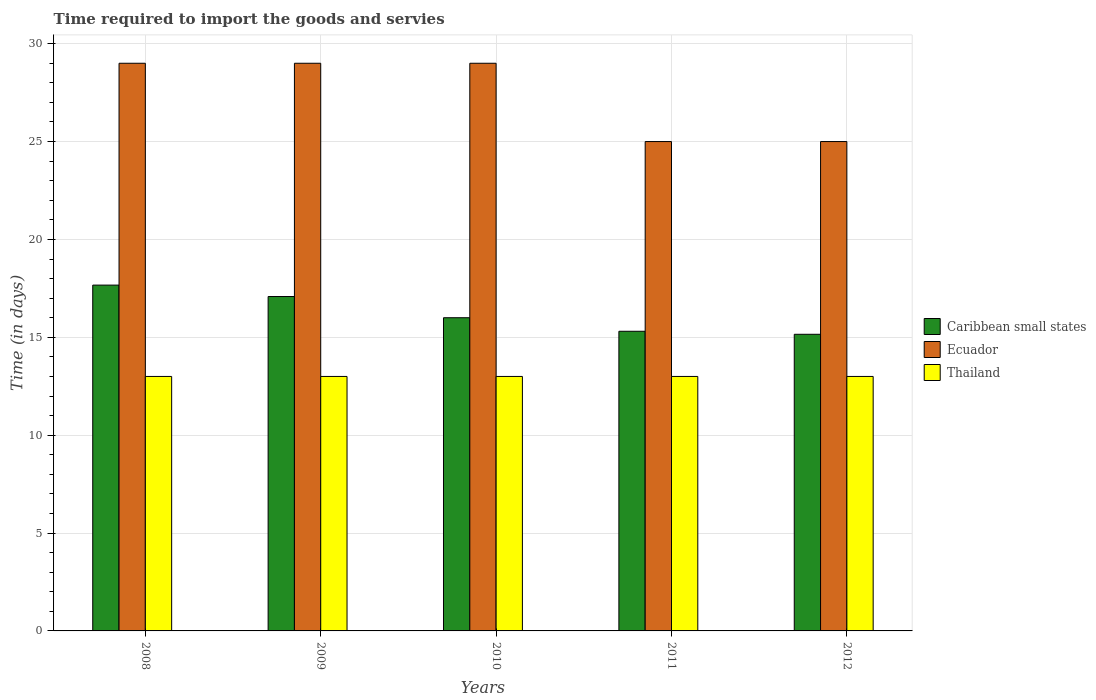How many different coloured bars are there?
Make the answer very short. 3. Are the number of bars on each tick of the X-axis equal?
Make the answer very short. Yes. How many bars are there on the 1st tick from the right?
Provide a short and direct response. 3. What is the label of the 1st group of bars from the left?
Your answer should be compact. 2008. In how many cases, is the number of bars for a given year not equal to the number of legend labels?
Provide a short and direct response. 0. What is the number of days required to import the goods and services in Caribbean small states in 2008?
Provide a succinct answer. 17.67. Across all years, what is the maximum number of days required to import the goods and services in Caribbean small states?
Make the answer very short. 17.67. Across all years, what is the minimum number of days required to import the goods and services in Thailand?
Make the answer very short. 13. In which year was the number of days required to import the goods and services in Caribbean small states maximum?
Keep it short and to the point. 2008. What is the total number of days required to import the goods and services in Ecuador in the graph?
Your response must be concise. 137. What is the difference between the number of days required to import the goods and services in Caribbean small states in 2010 and the number of days required to import the goods and services in Thailand in 2009?
Your answer should be compact. 3. What is the average number of days required to import the goods and services in Ecuador per year?
Offer a very short reply. 27.4. In the year 2012, what is the difference between the number of days required to import the goods and services in Caribbean small states and number of days required to import the goods and services in Ecuador?
Your response must be concise. -9.85. What is the ratio of the number of days required to import the goods and services in Ecuador in 2009 to that in 2012?
Make the answer very short. 1.16. What is the difference between the highest and the second highest number of days required to import the goods and services in Caribbean small states?
Ensure brevity in your answer.  0.58. In how many years, is the number of days required to import the goods and services in Thailand greater than the average number of days required to import the goods and services in Thailand taken over all years?
Ensure brevity in your answer.  0. Is the sum of the number of days required to import the goods and services in Ecuador in 2009 and 2010 greater than the maximum number of days required to import the goods and services in Thailand across all years?
Ensure brevity in your answer.  Yes. What does the 1st bar from the left in 2008 represents?
Offer a very short reply. Caribbean small states. What does the 1st bar from the right in 2010 represents?
Ensure brevity in your answer.  Thailand. Is it the case that in every year, the sum of the number of days required to import the goods and services in Ecuador and number of days required to import the goods and services in Thailand is greater than the number of days required to import the goods and services in Caribbean small states?
Your answer should be very brief. Yes. Are all the bars in the graph horizontal?
Your answer should be compact. No. What is the difference between two consecutive major ticks on the Y-axis?
Ensure brevity in your answer.  5. Are the values on the major ticks of Y-axis written in scientific E-notation?
Make the answer very short. No. Does the graph contain grids?
Offer a terse response. Yes. How many legend labels are there?
Keep it short and to the point. 3. How are the legend labels stacked?
Ensure brevity in your answer.  Vertical. What is the title of the graph?
Offer a terse response. Time required to import the goods and servies. Does "American Samoa" appear as one of the legend labels in the graph?
Provide a short and direct response. No. What is the label or title of the Y-axis?
Give a very brief answer. Time (in days). What is the Time (in days) in Caribbean small states in 2008?
Give a very brief answer. 17.67. What is the Time (in days) in Ecuador in 2008?
Offer a very short reply. 29. What is the Time (in days) in Thailand in 2008?
Provide a succinct answer. 13. What is the Time (in days) of Caribbean small states in 2009?
Your answer should be compact. 17.08. What is the Time (in days) in Ecuador in 2009?
Offer a very short reply. 29. What is the Time (in days) in Thailand in 2009?
Keep it short and to the point. 13. What is the Time (in days) of Caribbean small states in 2010?
Offer a terse response. 16. What is the Time (in days) in Thailand in 2010?
Your answer should be compact. 13. What is the Time (in days) in Caribbean small states in 2011?
Make the answer very short. 15.31. What is the Time (in days) of Thailand in 2011?
Your answer should be compact. 13. What is the Time (in days) of Caribbean small states in 2012?
Your response must be concise. 15.15. What is the Time (in days) in Thailand in 2012?
Your answer should be compact. 13. Across all years, what is the maximum Time (in days) in Caribbean small states?
Provide a short and direct response. 17.67. Across all years, what is the maximum Time (in days) of Thailand?
Give a very brief answer. 13. Across all years, what is the minimum Time (in days) of Caribbean small states?
Your response must be concise. 15.15. What is the total Time (in days) in Caribbean small states in the graph?
Keep it short and to the point. 81.21. What is the total Time (in days) in Ecuador in the graph?
Ensure brevity in your answer.  137. What is the total Time (in days) in Thailand in the graph?
Provide a succinct answer. 65. What is the difference between the Time (in days) of Caribbean small states in 2008 and that in 2009?
Provide a short and direct response. 0.58. What is the difference between the Time (in days) in Ecuador in 2008 and that in 2009?
Offer a very short reply. 0. What is the difference between the Time (in days) in Caribbean small states in 2008 and that in 2010?
Keep it short and to the point. 1.67. What is the difference between the Time (in days) in Caribbean small states in 2008 and that in 2011?
Provide a succinct answer. 2.36. What is the difference between the Time (in days) of Ecuador in 2008 and that in 2011?
Ensure brevity in your answer.  4. What is the difference between the Time (in days) of Caribbean small states in 2008 and that in 2012?
Keep it short and to the point. 2.51. What is the difference between the Time (in days) of Thailand in 2008 and that in 2012?
Offer a very short reply. 0. What is the difference between the Time (in days) in Caribbean small states in 2009 and that in 2011?
Your answer should be compact. 1.78. What is the difference between the Time (in days) in Thailand in 2009 and that in 2011?
Keep it short and to the point. 0. What is the difference between the Time (in days) in Caribbean small states in 2009 and that in 2012?
Offer a terse response. 1.93. What is the difference between the Time (in days) in Thailand in 2009 and that in 2012?
Give a very brief answer. 0. What is the difference between the Time (in days) of Caribbean small states in 2010 and that in 2011?
Offer a terse response. 0.69. What is the difference between the Time (in days) of Ecuador in 2010 and that in 2011?
Keep it short and to the point. 4. What is the difference between the Time (in days) of Thailand in 2010 and that in 2011?
Offer a very short reply. 0. What is the difference between the Time (in days) of Caribbean small states in 2010 and that in 2012?
Make the answer very short. 0.85. What is the difference between the Time (in days) in Caribbean small states in 2011 and that in 2012?
Offer a very short reply. 0.15. What is the difference between the Time (in days) of Ecuador in 2011 and that in 2012?
Offer a terse response. 0. What is the difference between the Time (in days) in Thailand in 2011 and that in 2012?
Keep it short and to the point. 0. What is the difference between the Time (in days) in Caribbean small states in 2008 and the Time (in days) in Ecuador in 2009?
Keep it short and to the point. -11.33. What is the difference between the Time (in days) of Caribbean small states in 2008 and the Time (in days) of Thailand in 2009?
Offer a terse response. 4.67. What is the difference between the Time (in days) of Ecuador in 2008 and the Time (in days) of Thailand in 2009?
Offer a terse response. 16. What is the difference between the Time (in days) of Caribbean small states in 2008 and the Time (in days) of Ecuador in 2010?
Provide a succinct answer. -11.33. What is the difference between the Time (in days) of Caribbean small states in 2008 and the Time (in days) of Thailand in 2010?
Ensure brevity in your answer.  4.67. What is the difference between the Time (in days) of Ecuador in 2008 and the Time (in days) of Thailand in 2010?
Keep it short and to the point. 16. What is the difference between the Time (in days) of Caribbean small states in 2008 and the Time (in days) of Ecuador in 2011?
Keep it short and to the point. -7.33. What is the difference between the Time (in days) in Caribbean small states in 2008 and the Time (in days) in Thailand in 2011?
Keep it short and to the point. 4.67. What is the difference between the Time (in days) of Ecuador in 2008 and the Time (in days) of Thailand in 2011?
Provide a succinct answer. 16. What is the difference between the Time (in days) in Caribbean small states in 2008 and the Time (in days) in Ecuador in 2012?
Your answer should be compact. -7.33. What is the difference between the Time (in days) of Caribbean small states in 2008 and the Time (in days) of Thailand in 2012?
Keep it short and to the point. 4.67. What is the difference between the Time (in days) in Ecuador in 2008 and the Time (in days) in Thailand in 2012?
Your answer should be very brief. 16. What is the difference between the Time (in days) in Caribbean small states in 2009 and the Time (in days) in Ecuador in 2010?
Your response must be concise. -11.92. What is the difference between the Time (in days) of Caribbean small states in 2009 and the Time (in days) of Thailand in 2010?
Give a very brief answer. 4.08. What is the difference between the Time (in days) in Ecuador in 2009 and the Time (in days) in Thailand in 2010?
Make the answer very short. 16. What is the difference between the Time (in days) in Caribbean small states in 2009 and the Time (in days) in Ecuador in 2011?
Offer a very short reply. -7.92. What is the difference between the Time (in days) in Caribbean small states in 2009 and the Time (in days) in Thailand in 2011?
Keep it short and to the point. 4.08. What is the difference between the Time (in days) of Caribbean small states in 2009 and the Time (in days) of Ecuador in 2012?
Ensure brevity in your answer.  -7.92. What is the difference between the Time (in days) in Caribbean small states in 2009 and the Time (in days) in Thailand in 2012?
Provide a succinct answer. 4.08. What is the difference between the Time (in days) of Caribbean small states in 2010 and the Time (in days) of Ecuador in 2011?
Provide a short and direct response. -9. What is the difference between the Time (in days) in Caribbean small states in 2010 and the Time (in days) in Thailand in 2011?
Offer a very short reply. 3. What is the difference between the Time (in days) of Caribbean small states in 2010 and the Time (in days) of Thailand in 2012?
Ensure brevity in your answer.  3. What is the difference between the Time (in days) of Caribbean small states in 2011 and the Time (in days) of Ecuador in 2012?
Provide a succinct answer. -9.69. What is the difference between the Time (in days) of Caribbean small states in 2011 and the Time (in days) of Thailand in 2012?
Give a very brief answer. 2.31. What is the average Time (in days) in Caribbean small states per year?
Provide a short and direct response. 16.24. What is the average Time (in days) of Ecuador per year?
Keep it short and to the point. 27.4. What is the average Time (in days) of Thailand per year?
Ensure brevity in your answer.  13. In the year 2008, what is the difference between the Time (in days) of Caribbean small states and Time (in days) of Ecuador?
Provide a short and direct response. -11.33. In the year 2008, what is the difference between the Time (in days) of Caribbean small states and Time (in days) of Thailand?
Your answer should be compact. 4.67. In the year 2008, what is the difference between the Time (in days) in Ecuador and Time (in days) in Thailand?
Your answer should be compact. 16. In the year 2009, what is the difference between the Time (in days) in Caribbean small states and Time (in days) in Ecuador?
Keep it short and to the point. -11.92. In the year 2009, what is the difference between the Time (in days) in Caribbean small states and Time (in days) in Thailand?
Offer a very short reply. 4.08. In the year 2009, what is the difference between the Time (in days) in Ecuador and Time (in days) in Thailand?
Offer a very short reply. 16. In the year 2011, what is the difference between the Time (in days) in Caribbean small states and Time (in days) in Ecuador?
Give a very brief answer. -9.69. In the year 2011, what is the difference between the Time (in days) of Caribbean small states and Time (in days) of Thailand?
Provide a succinct answer. 2.31. In the year 2012, what is the difference between the Time (in days) of Caribbean small states and Time (in days) of Ecuador?
Make the answer very short. -9.85. In the year 2012, what is the difference between the Time (in days) of Caribbean small states and Time (in days) of Thailand?
Offer a terse response. 2.15. In the year 2012, what is the difference between the Time (in days) of Ecuador and Time (in days) of Thailand?
Keep it short and to the point. 12. What is the ratio of the Time (in days) of Caribbean small states in 2008 to that in 2009?
Give a very brief answer. 1.03. What is the ratio of the Time (in days) of Thailand in 2008 to that in 2009?
Offer a very short reply. 1. What is the ratio of the Time (in days) of Caribbean small states in 2008 to that in 2010?
Keep it short and to the point. 1.1. What is the ratio of the Time (in days) of Ecuador in 2008 to that in 2010?
Your answer should be very brief. 1. What is the ratio of the Time (in days) of Caribbean small states in 2008 to that in 2011?
Your answer should be very brief. 1.15. What is the ratio of the Time (in days) of Ecuador in 2008 to that in 2011?
Offer a terse response. 1.16. What is the ratio of the Time (in days) in Caribbean small states in 2008 to that in 2012?
Ensure brevity in your answer.  1.17. What is the ratio of the Time (in days) in Ecuador in 2008 to that in 2012?
Your response must be concise. 1.16. What is the ratio of the Time (in days) of Thailand in 2008 to that in 2012?
Give a very brief answer. 1. What is the ratio of the Time (in days) in Caribbean small states in 2009 to that in 2010?
Provide a short and direct response. 1.07. What is the ratio of the Time (in days) of Ecuador in 2009 to that in 2010?
Give a very brief answer. 1. What is the ratio of the Time (in days) in Caribbean small states in 2009 to that in 2011?
Give a very brief answer. 1.12. What is the ratio of the Time (in days) of Ecuador in 2009 to that in 2011?
Your answer should be compact. 1.16. What is the ratio of the Time (in days) of Thailand in 2009 to that in 2011?
Your answer should be very brief. 1. What is the ratio of the Time (in days) in Caribbean small states in 2009 to that in 2012?
Provide a succinct answer. 1.13. What is the ratio of the Time (in days) of Ecuador in 2009 to that in 2012?
Make the answer very short. 1.16. What is the ratio of the Time (in days) in Thailand in 2009 to that in 2012?
Ensure brevity in your answer.  1. What is the ratio of the Time (in days) of Caribbean small states in 2010 to that in 2011?
Ensure brevity in your answer.  1.05. What is the ratio of the Time (in days) in Ecuador in 2010 to that in 2011?
Ensure brevity in your answer.  1.16. What is the ratio of the Time (in days) in Thailand in 2010 to that in 2011?
Keep it short and to the point. 1. What is the ratio of the Time (in days) of Caribbean small states in 2010 to that in 2012?
Offer a very short reply. 1.06. What is the ratio of the Time (in days) of Ecuador in 2010 to that in 2012?
Offer a very short reply. 1.16. What is the ratio of the Time (in days) of Thailand in 2010 to that in 2012?
Your response must be concise. 1. What is the ratio of the Time (in days) in Caribbean small states in 2011 to that in 2012?
Keep it short and to the point. 1.01. What is the ratio of the Time (in days) in Ecuador in 2011 to that in 2012?
Provide a short and direct response. 1. What is the difference between the highest and the second highest Time (in days) of Caribbean small states?
Your answer should be compact. 0.58. What is the difference between the highest and the second highest Time (in days) in Ecuador?
Your answer should be compact. 0. What is the difference between the highest and the lowest Time (in days) in Caribbean small states?
Offer a very short reply. 2.51. What is the difference between the highest and the lowest Time (in days) of Ecuador?
Your answer should be compact. 4. What is the difference between the highest and the lowest Time (in days) of Thailand?
Your response must be concise. 0. 